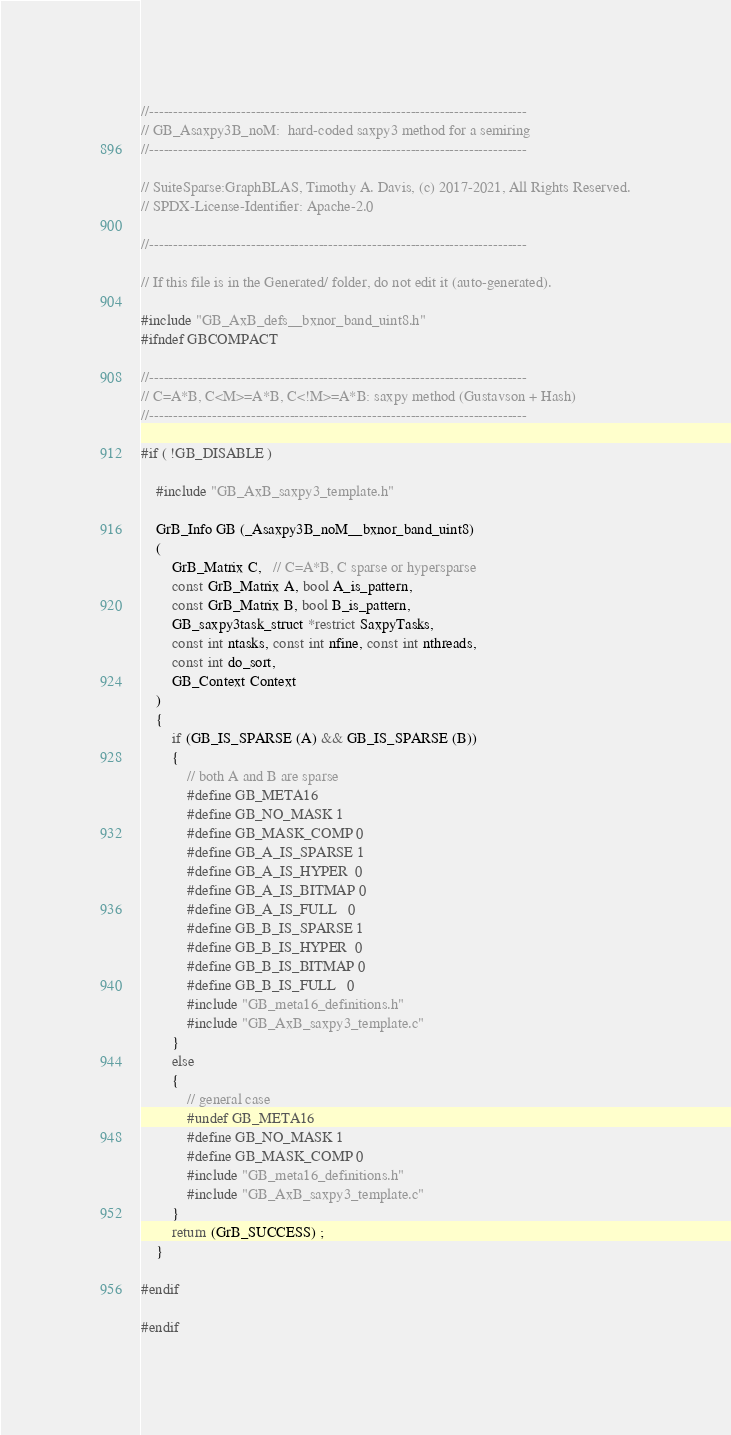Convert code to text. <code><loc_0><loc_0><loc_500><loc_500><_C_>//------------------------------------------------------------------------------
// GB_Asaxpy3B_noM:  hard-coded saxpy3 method for a semiring
//------------------------------------------------------------------------------

// SuiteSparse:GraphBLAS, Timothy A. Davis, (c) 2017-2021, All Rights Reserved.
// SPDX-License-Identifier: Apache-2.0

//------------------------------------------------------------------------------

// If this file is in the Generated/ folder, do not edit it (auto-generated).

#include "GB_AxB_defs__bxnor_band_uint8.h"
#ifndef GBCOMPACT

//------------------------------------------------------------------------------
// C=A*B, C<M>=A*B, C<!M>=A*B: saxpy method (Gustavson + Hash)
//------------------------------------------------------------------------------

#if ( !GB_DISABLE )

    #include "GB_AxB_saxpy3_template.h"

    GrB_Info GB (_Asaxpy3B_noM__bxnor_band_uint8)
    (
        GrB_Matrix C,   // C=A*B, C sparse or hypersparse
        const GrB_Matrix A, bool A_is_pattern,
        const GrB_Matrix B, bool B_is_pattern,
        GB_saxpy3task_struct *restrict SaxpyTasks,
        const int ntasks, const int nfine, const int nthreads,
        const int do_sort,
        GB_Context Context
    )
    {
        if (GB_IS_SPARSE (A) && GB_IS_SPARSE (B))
        {
            // both A and B are sparse
            #define GB_META16
            #define GB_NO_MASK 1
            #define GB_MASK_COMP 0
            #define GB_A_IS_SPARSE 1
            #define GB_A_IS_HYPER  0
            #define GB_A_IS_BITMAP 0
            #define GB_A_IS_FULL   0
            #define GB_B_IS_SPARSE 1
            #define GB_B_IS_HYPER  0
            #define GB_B_IS_BITMAP 0
            #define GB_B_IS_FULL   0
            #include "GB_meta16_definitions.h"
            #include "GB_AxB_saxpy3_template.c"
        }
        else
        {
            // general case
            #undef GB_META16
            #define GB_NO_MASK 1
            #define GB_MASK_COMP 0
            #include "GB_meta16_definitions.h"
            #include "GB_AxB_saxpy3_template.c"
        }
        return (GrB_SUCCESS) ;
    }

#endif

#endif

</code> 